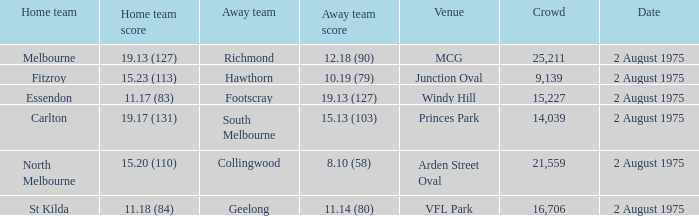In which location did the home team achieve a score of 11.18 (84)? VFL Park. 